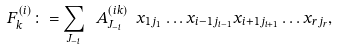Convert formula to latex. <formula><loc_0><loc_0><loc_500><loc_500>F ^ { ( i ) } _ { k } \colon = \sum _ { J _ { - i } } \ A ^ { ( i k ) } _ { J _ { - i } } \ x _ { 1 j _ { 1 } } \dots x _ { { i - 1 } j _ { i - 1 } } x _ { { i + 1 } j _ { i + 1 } } \dots x _ { r j _ { r } } ,</formula> 